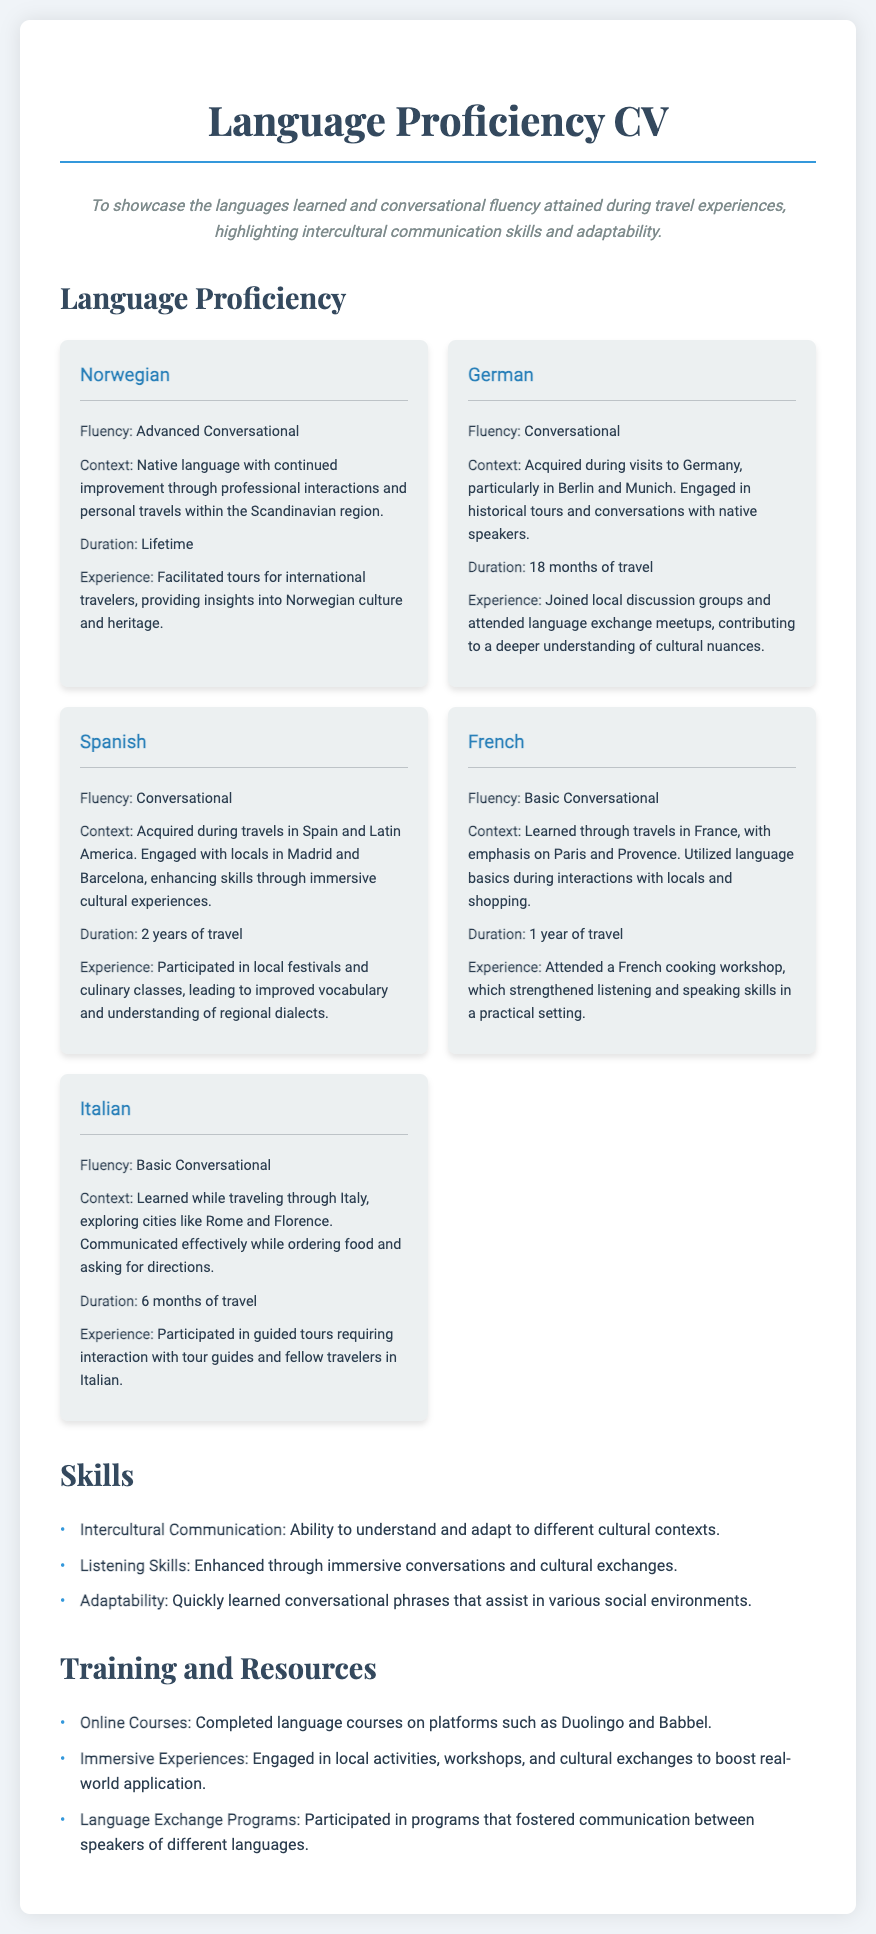What is the native language of the traveler? The native language is specified in the document under the section for Norwegian, indicating it is the traveler's primary language.
Answer: Norwegian How many years of travel experience does the traveler have with Spanish? The document states the duration of Spanish language acquisition as 2 years of travel.
Answer: 2 years Which language has an advanced conversational fluency? The document highlights Norwegian as the language in which the traveler has advanced conversational fluency.
Answer: Norwegian What type of experiences contributed to learning German? The document indicates that the traveler engaged in historical tours and conversations with native speakers during visits to Germany.
Answer: Historical tours How long did the traveler learn French? The document specifies that the traveler had 1 year of travel experience learning French.
Answer: 1 year What cultural activity did the traveler participate in while learning Italian? The document mentions that the traveler participated in guided tours as part of their language learning experience in Italian.
Answer: Guided tours Which language requires basic conversational skills according to the document? The document provides details that both French and Italian are at a basic conversational fluency level.
Answer: French, Italian What online platforms were used for language training? The document lists Duolingo and Babbel as the platforms for completed language courses.
Answer: Duolingo and Babbel What communication skill is emphasized in the document? The skills section highlights intercultural communication as a significant ability of the traveler.
Answer: Intercultural Communication 